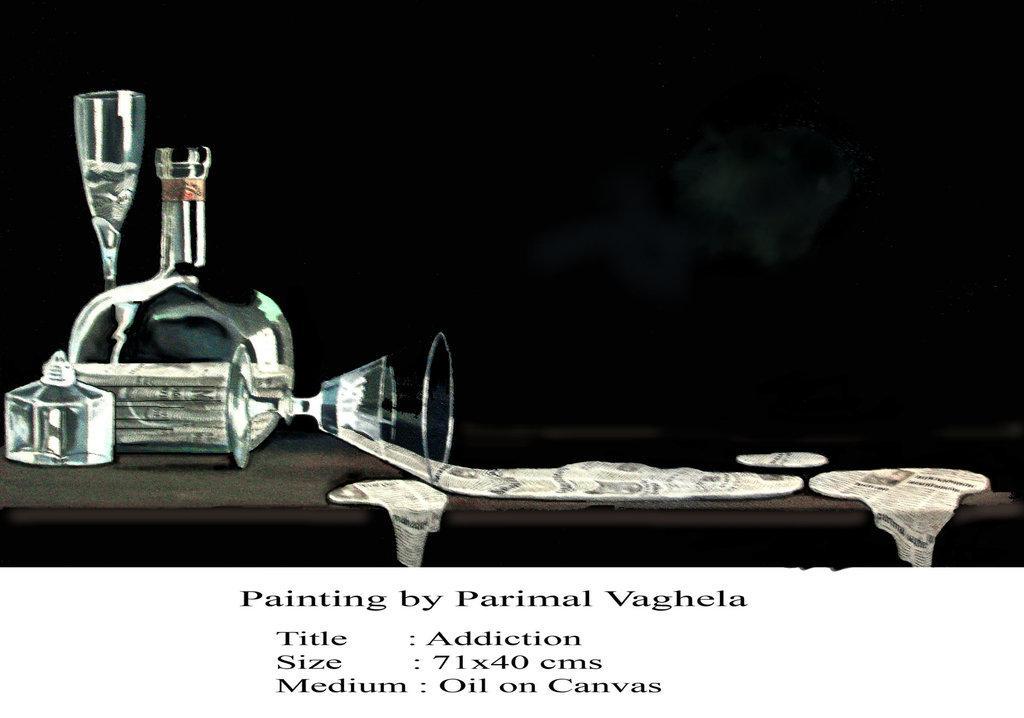In one or two sentences, can you explain what this image depicts? In the image there are glass flask and wine glass painting on a table and over bottom a text written painting by parimal vaghela. 